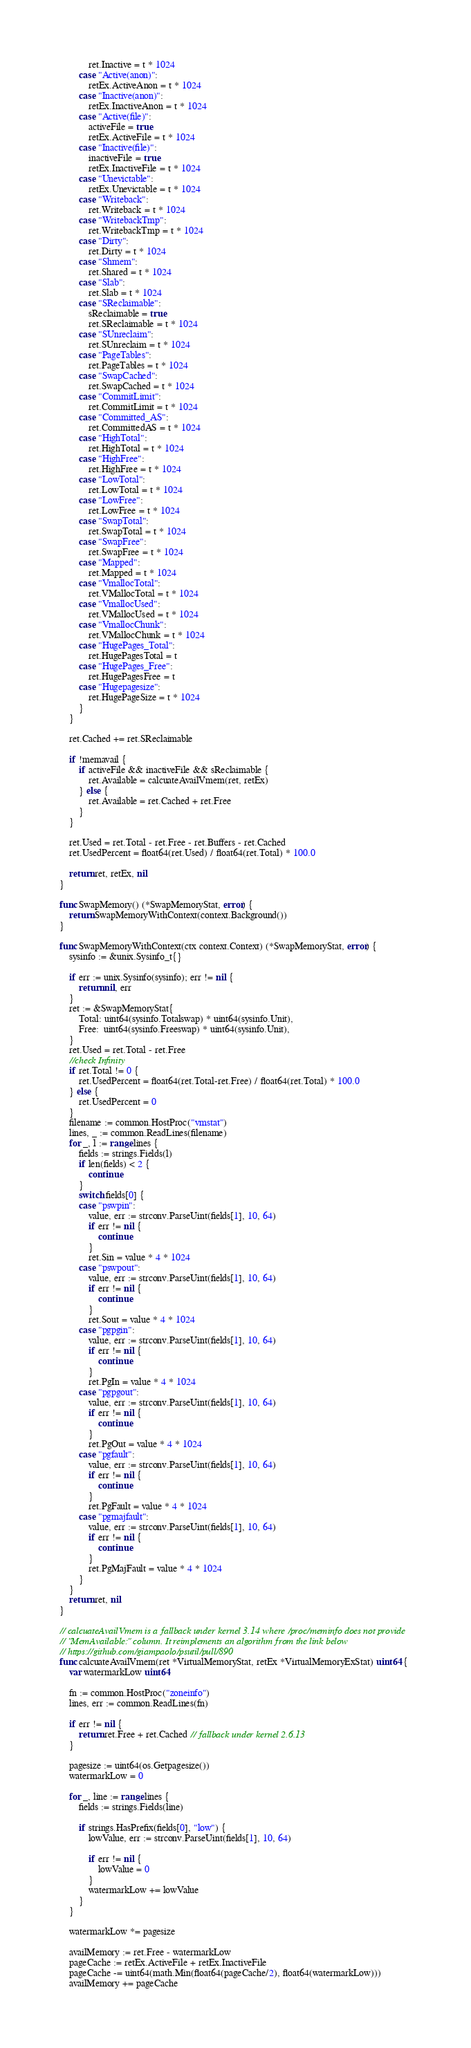<code> <loc_0><loc_0><loc_500><loc_500><_Go_>			ret.Inactive = t * 1024
		case "Active(anon)":
			retEx.ActiveAnon = t * 1024
		case "Inactive(anon)":
			retEx.InactiveAnon = t * 1024
		case "Active(file)":
			activeFile = true
			retEx.ActiveFile = t * 1024
		case "Inactive(file)":
			inactiveFile = true
			retEx.InactiveFile = t * 1024
		case "Unevictable":
			retEx.Unevictable = t * 1024
		case "Writeback":
			ret.Writeback = t * 1024
		case "WritebackTmp":
			ret.WritebackTmp = t * 1024
		case "Dirty":
			ret.Dirty = t * 1024
		case "Shmem":
			ret.Shared = t * 1024
		case "Slab":
			ret.Slab = t * 1024
		case "SReclaimable":
			sReclaimable = true
			ret.SReclaimable = t * 1024
		case "SUnreclaim":
			ret.SUnreclaim = t * 1024
		case "PageTables":
			ret.PageTables = t * 1024
		case "SwapCached":
			ret.SwapCached = t * 1024
		case "CommitLimit":
			ret.CommitLimit = t * 1024
		case "Committed_AS":
			ret.CommittedAS = t * 1024
		case "HighTotal":
			ret.HighTotal = t * 1024
		case "HighFree":
			ret.HighFree = t * 1024
		case "LowTotal":
			ret.LowTotal = t * 1024
		case "LowFree":
			ret.LowFree = t * 1024
		case "SwapTotal":
			ret.SwapTotal = t * 1024
		case "SwapFree":
			ret.SwapFree = t * 1024
		case "Mapped":
			ret.Mapped = t * 1024
		case "VmallocTotal":
			ret.VMallocTotal = t * 1024
		case "VmallocUsed":
			ret.VMallocUsed = t * 1024
		case "VmallocChunk":
			ret.VMallocChunk = t * 1024
		case "HugePages_Total":
			ret.HugePagesTotal = t
		case "HugePages_Free":
			ret.HugePagesFree = t
		case "Hugepagesize":
			ret.HugePageSize = t * 1024
		}
	}

	ret.Cached += ret.SReclaimable

	if !memavail {
		if activeFile && inactiveFile && sReclaimable {
			ret.Available = calcuateAvailVmem(ret, retEx)
		} else {
			ret.Available = ret.Cached + ret.Free
		}
	}

	ret.Used = ret.Total - ret.Free - ret.Buffers - ret.Cached
	ret.UsedPercent = float64(ret.Used) / float64(ret.Total) * 100.0

	return ret, retEx, nil
}

func SwapMemory() (*SwapMemoryStat, error) {
	return SwapMemoryWithContext(context.Background())
}

func SwapMemoryWithContext(ctx context.Context) (*SwapMemoryStat, error) {
	sysinfo := &unix.Sysinfo_t{}

	if err := unix.Sysinfo(sysinfo); err != nil {
		return nil, err
	}
	ret := &SwapMemoryStat{
		Total: uint64(sysinfo.Totalswap) * uint64(sysinfo.Unit),
		Free:  uint64(sysinfo.Freeswap) * uint64(sysinfo.Unit),
	}
	ret.Used = ret.Total - ret.Free
	//check Infinity
	if ret.Total != 0 {
		ret.UsedPercent = float64(ret.Total-ret.Free) / float64(ret.Total) * 100.0
	} else {
		ret.UsedPercent = 0
	}
	filename := common.HostProc("vmstat")
	lines, _ := common.ReadLines(filename)
	for _, l := range lines {
		fields := strings.Fields(l)
		if len(fields) < 2 {
			continue
		}
		switch fields[0] {
		case "pswpin":
			value, err := strconv.ParseUint(fields[1], 10, 64)
			if err != nil {
				continue
			}
			ret.Sin = value * 4 * 1024
		case "pswpout":
			value, err := strconv.ParseUint(fields[1], 10, 64)
			if err != nil {
				continue
			}
			ret.Sout = value * 4 * 1024
		case "pgpgin":
			value, err := strconv.ParseUint(fields[1], 10, 64)
			if err != nil {
				continue
			}
			ret.PgIn = value * 4 * 1024
		case "pgpgout":
			value, err := strconv.ParseUint(fields[1], 10, 64)
			if err != nil {
				continue
			}
			ret.PgOut = value * 4 * 1024
		case "pgfault":
			value, err := strconv.ParseUint(fields[1], 10, 64)
			if err != nil {
				continue
			}
			ret.PgFault = value * 4 * 1024
		case "pgmajfault":
			value, err := strconv.ParseUint(fields[1], 10, 64)
			if err != nil {
				continue
			}
			ret.PgMajFault = value * 4 * 1024
		}
	}
	return ret, nil
}

// calcuateAvailVmem is a fallback under kernel 3.14 where /proc/meminfo does not provide
// "MemAvailable:" column. It reimplements an algorithm from the link below
// https://github.com/giampaolo/psutil/pull/890
func calcuateAvailVmem(ret *VirtualMemoryStat, retEx *VirtualMemoryExStat) uint64 {
	var watermarkLow uint64

	fn := common.HostProc("zoneinfo")
	lines, err := common.ReadLines(fn)

	if err != nil {
		return ret.Free + ret.Cached // fallback under kernel 2.6.13
	}

	pagesize := uint64(os.Getpagesize())
	watermarkLow = 0

	for _, line := range lines {
		fields := strings.Fields(line)

		if strings.HasPrefix(fields[0], "low") {
			lowValue, err := strconv.ParseUint(fields[1], 10, 64)

			if err != nil {
				lowValue = 0
			}
			watermarkLow += lowValue
		}
	}

	watermarkLow *= pagesize

	availMemory := ret.Free - watermarkLow
	pageCache := retEx.ActiveFile + retEx.InactiveFile
	pageCache -= uint64(math.Min(float64(pageCache/2), float64(watermarkLow)))
	availMemory += pageCache</code> 